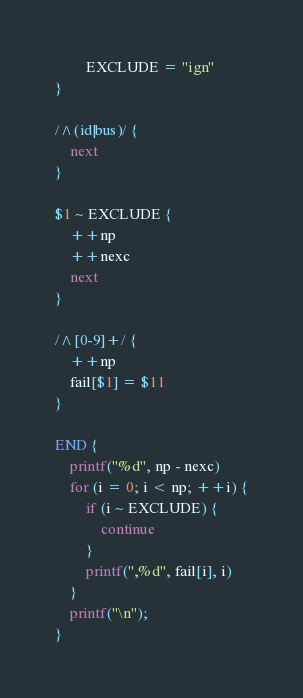Convert code to text. <code><loc_0><loc_0><loc_500><loc_500><_Awk_>		EXCLUDE = "ign"
}

/^(id|bus)/ {
	next
}

$1 ~ EXCLUDE {
	++np
	++nexc
	next
}

/^[0-9]+/ {
	++np
	fail[$1] = $11
}

END {
	printf("%d", np - nexc)
	for (i = 0; i < np; ++i) {
		if (i ~ EXCLUDE) {
			continue
		}
		printf(",%d", fail[i], i)
	}
	printf("\n");
}
</code> 